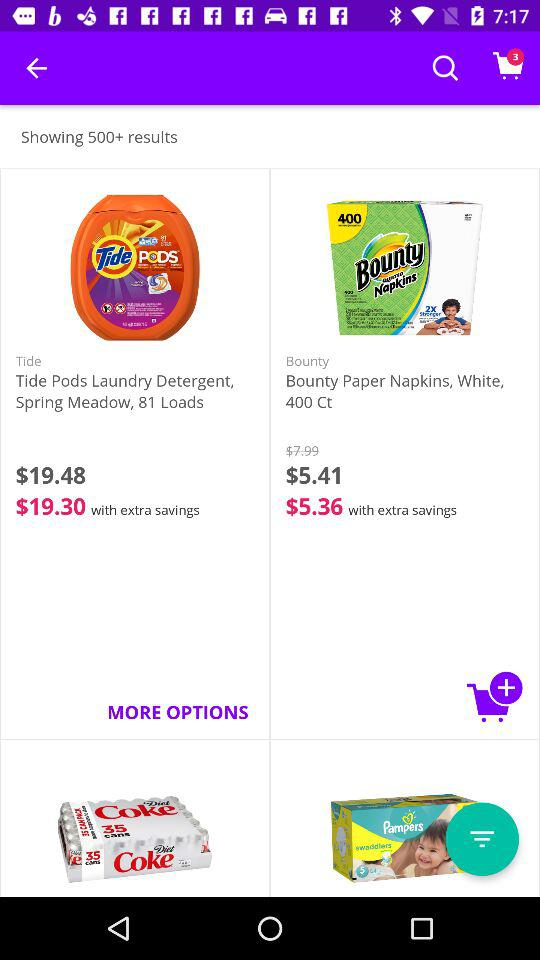What is the price of "Tide Pods Laundry Detergent" after saving? The price after savings is $19.30. 